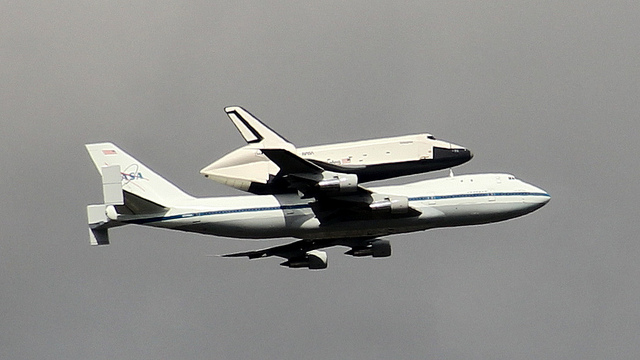Extract all visible text content from this image. ASA 